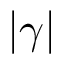Convert formula to latex. <formula><loc_0><loc_0><loc_500><loc_500>| \gamma |</formula> 